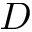Convert formula to latex. <formula><loc_0><loc_0><loc_500><loc_500>D</formula> 